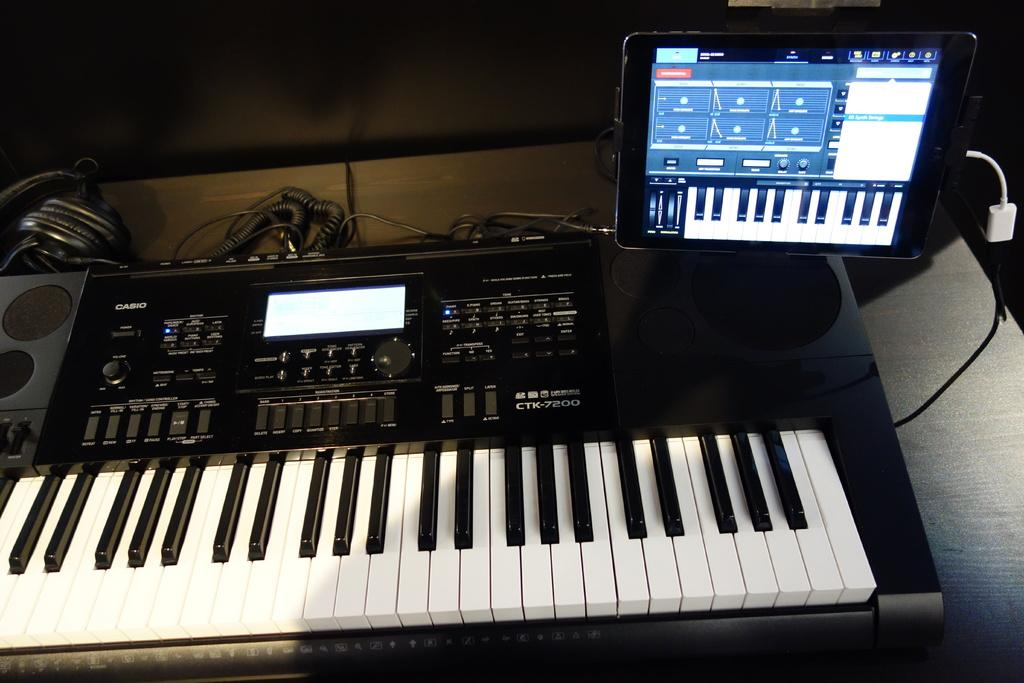What musical instrument is present in the image? There is a piano in the image. What electronic device can be seen on a table in the image? There is a screen on a table in the image. What type of rock is being stitched together in the image? There is no rock or stitching present in the image; it features a piano and a screen on a table. 